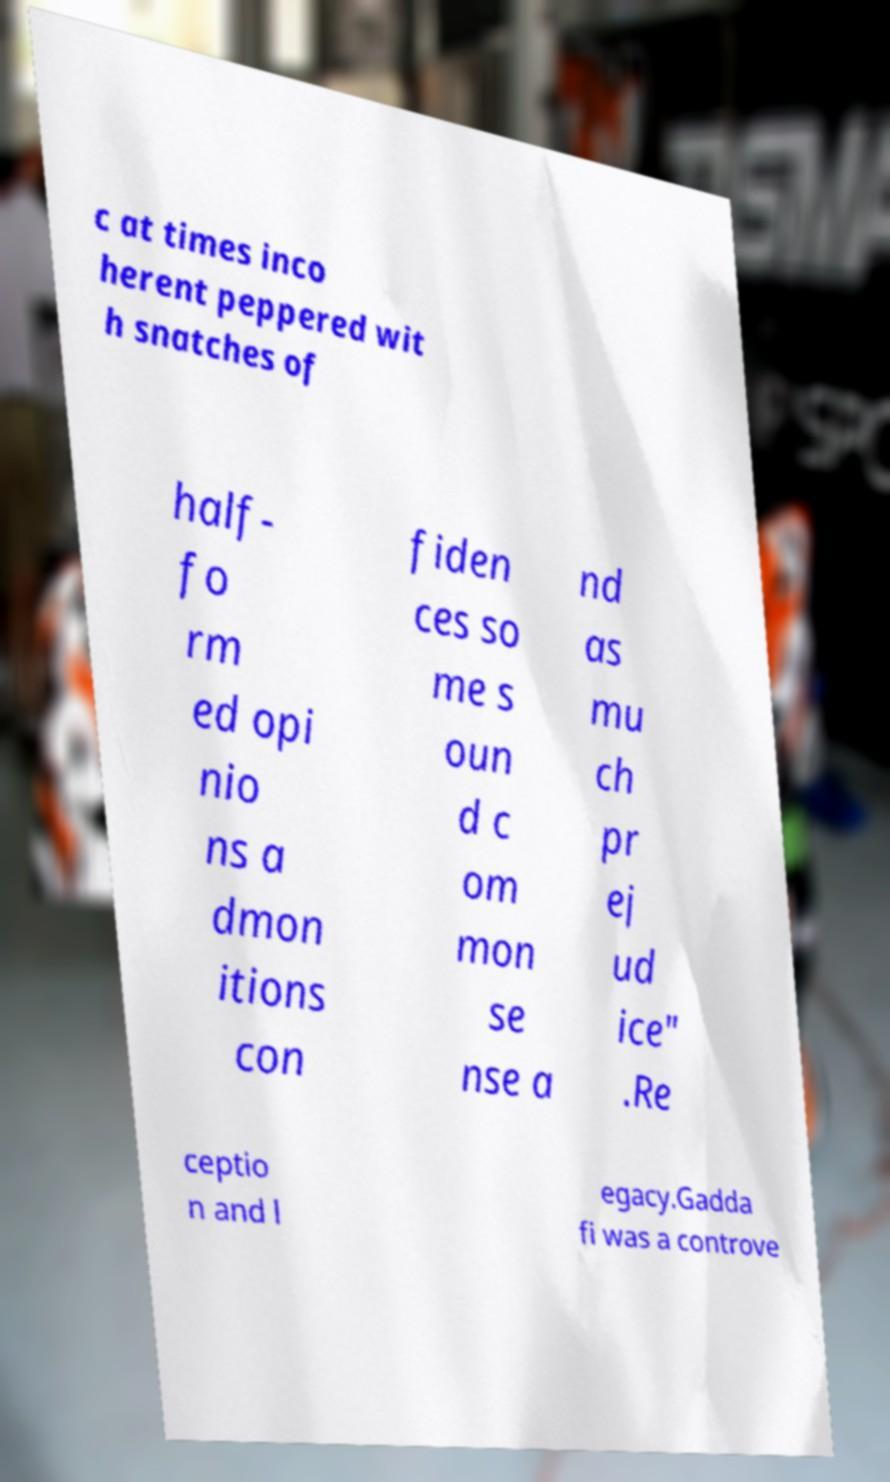What messages or text are displayed in this image? I need them in a readable, typed format. c at times inco herent peppered wit h snatches of half- fo rm ed opi nio ns a dmon itions con fiden ces so me s oun d c om mon se nse a nd as mu ch pr ej ud ice" .Re ceptio n and l egacy.Gadda fi was a controve 